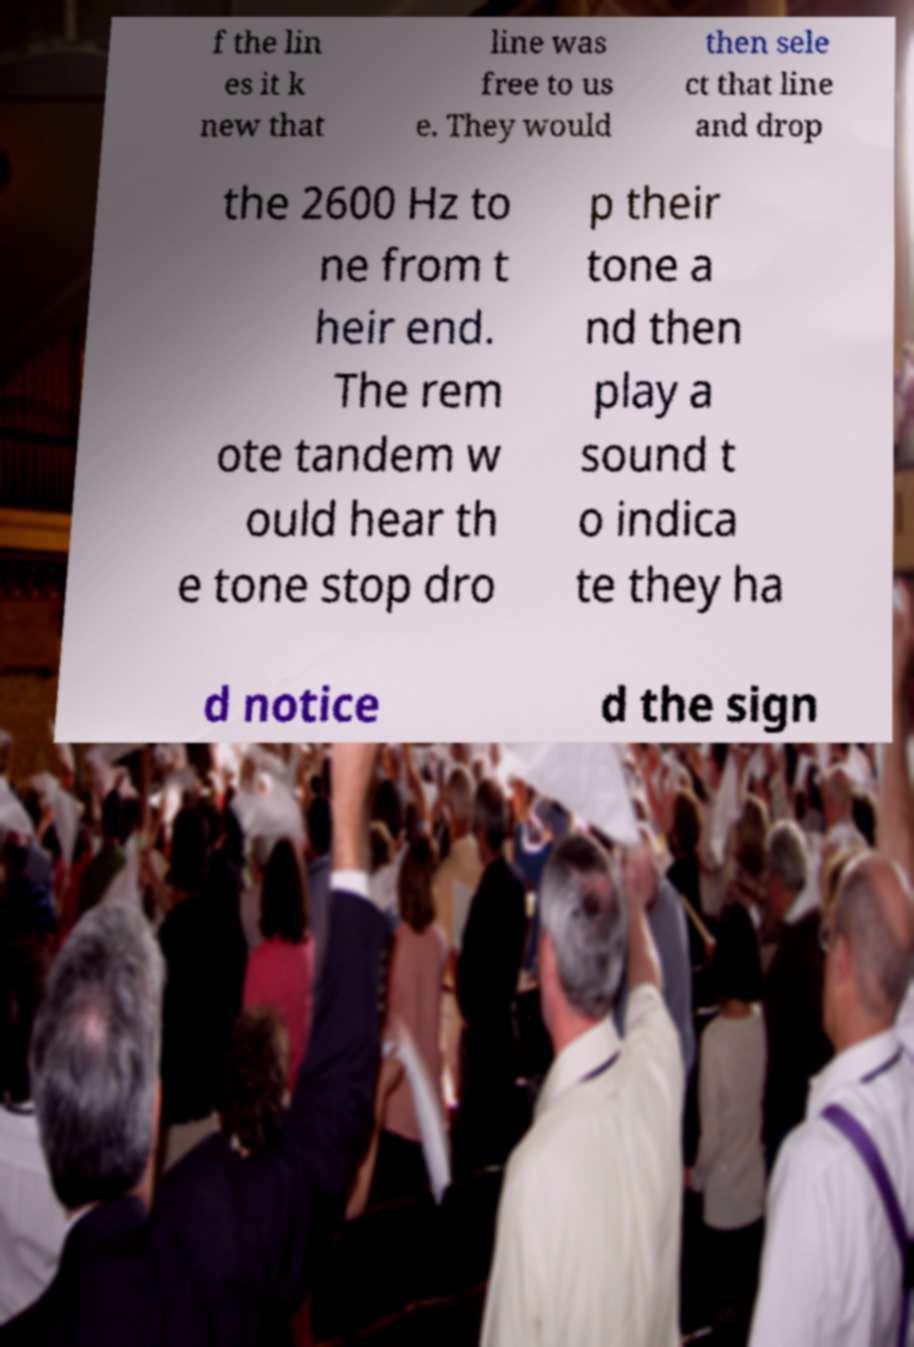Can you read and provide the text displayed in the image?This photo seems to have some interesting text. Can you extract and type it out for me? f the lin es it k new that line was free to us e. They would then sele ct that line and drop the 2600 Hz to ne from t heir end. The rem ote tandem w ould hear th e tone stop dro p their tone a nd then play a sound t o indica te they ha d notice d the sign 